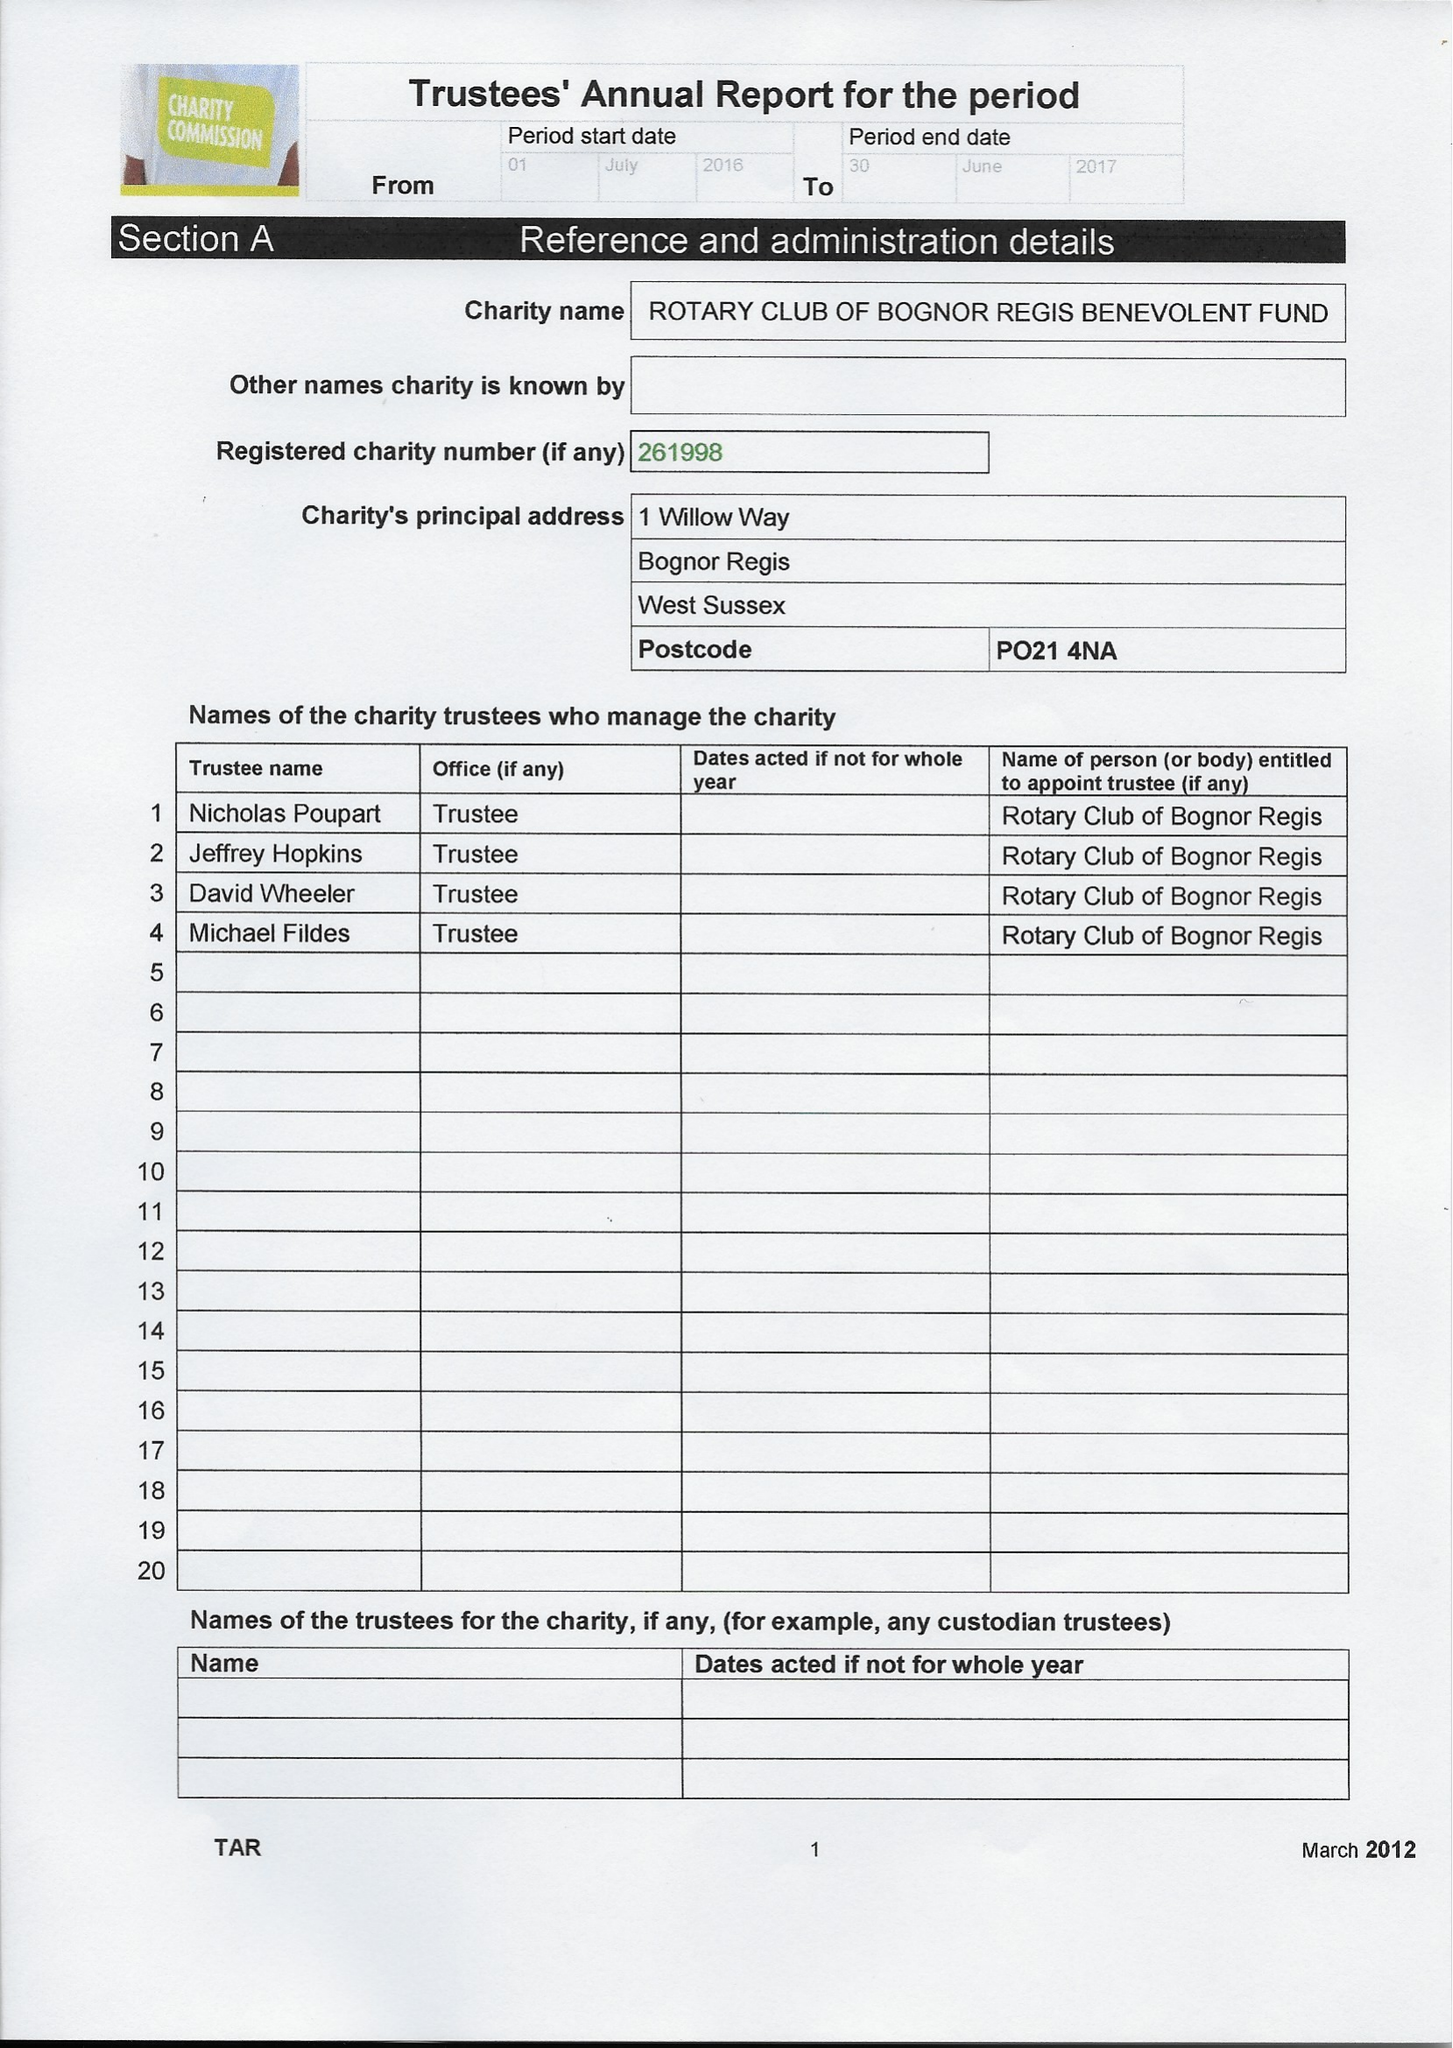What is the value for the charity_number?
Answer the question using a single word or phrase. 261998 